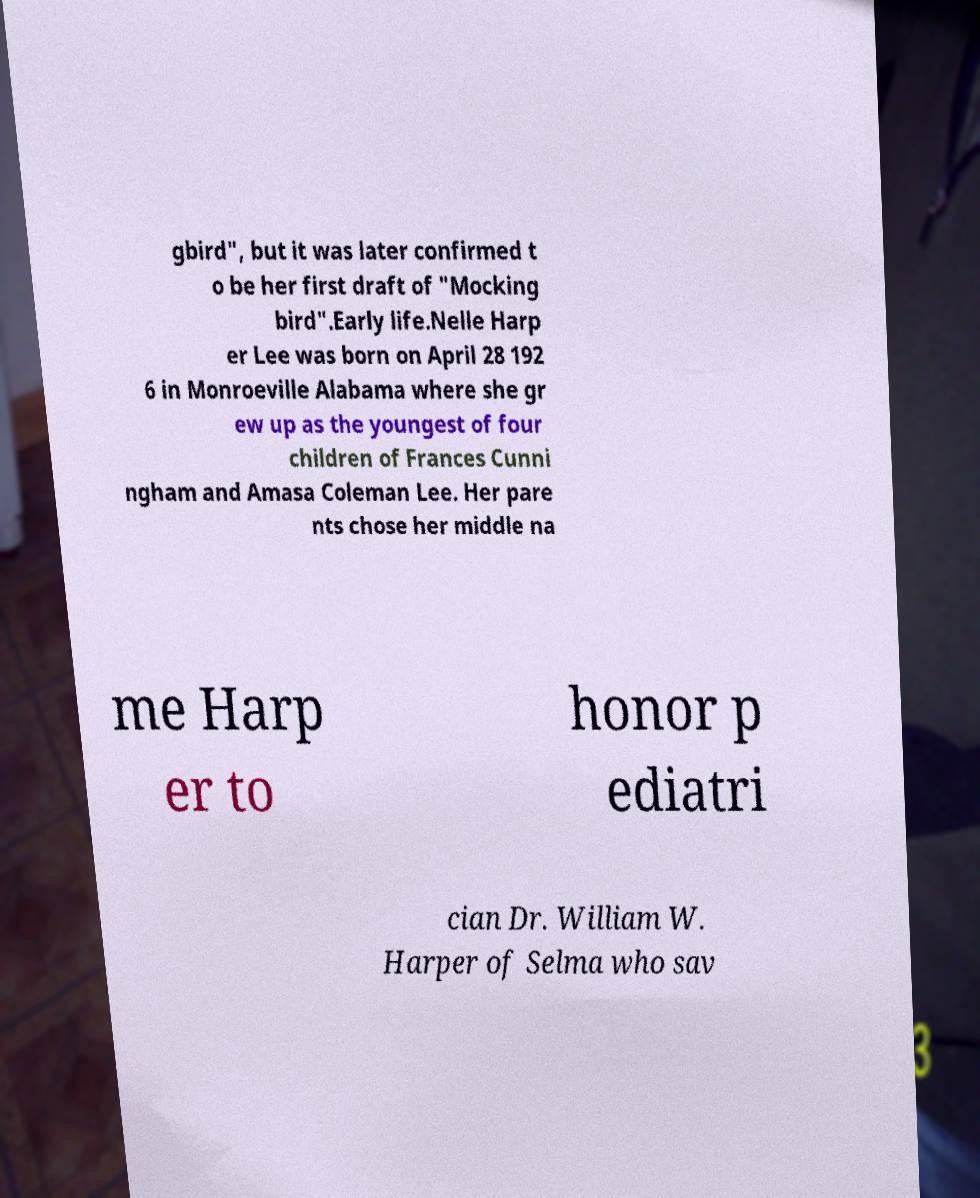Please read and relay the text visible in this image. What does it say? gbird", but it was later confirmed t o be her first draft of "Mocking bird".Early life.Nelle Harp er Lee was born on April 28 192 6 in Monroeville Alabama where she gr ew up as the youngest of four children of Frances Cunni ngham and Amasa Coleman Lee. Her pare nts chose her middle na me Harp er to honor p ediatri cian Dr. William W. Harper of Selma who sav 